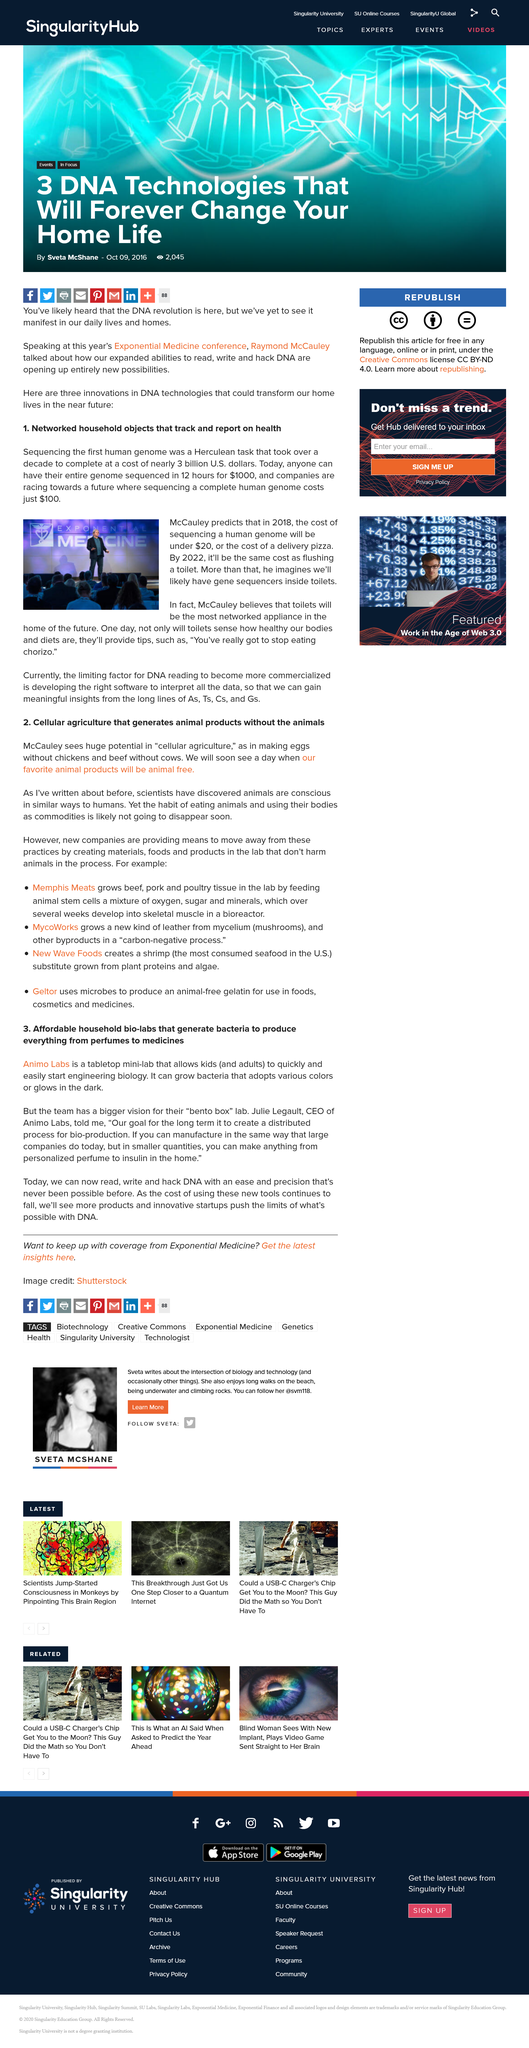Identify some key points in this picture. The first human genome was sequenced over a decade. Amino Labs is a tabletop mini-lab that enables children and adults to initiate engineering biology with ease, provided by its CEO, Julie Legault. McCauley predicts that toilets will be the most networked appliance in the home of the future. Yes, Animo Labs is capable of growing bacteria that exhibits diverse colors. The goal of Amino Labs is to enable individuals to create a wide range of products, such as personalized perfume and insulin, in the comfort and convenience of their own homes. 